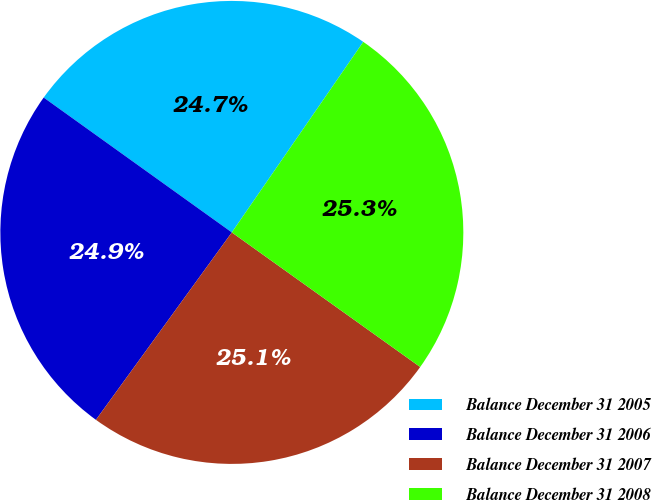<chart> <loc_0><loc_0><loc_500><loc_500><pie_chart><fcel>Balance December 31 2005<fcel>Balance December 31 2006<fcel>Balance December 31 2007<fcel>Balance December 31 2008<nl><fcel>24.71%<fcel>24.91%<fcel>25.11%<fcel>25.26%<nl></chart> 